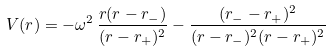Convert formula to latex. <formula><loc_0><loc_0><loc_500><loc_500>V ( r ) = - \omega ^ { 2 } \, \frac { r ( r - r _ { - } ) } { ( r - r _ { + } ) ^ { 2 } } - \frac { ( r _ { - } - r _ { + } ) ^ { 2 } } { ( r - r _ { - } ) ^ { 2 } ( r - r _ { + } ) ^ { 2 } } \</formula> 